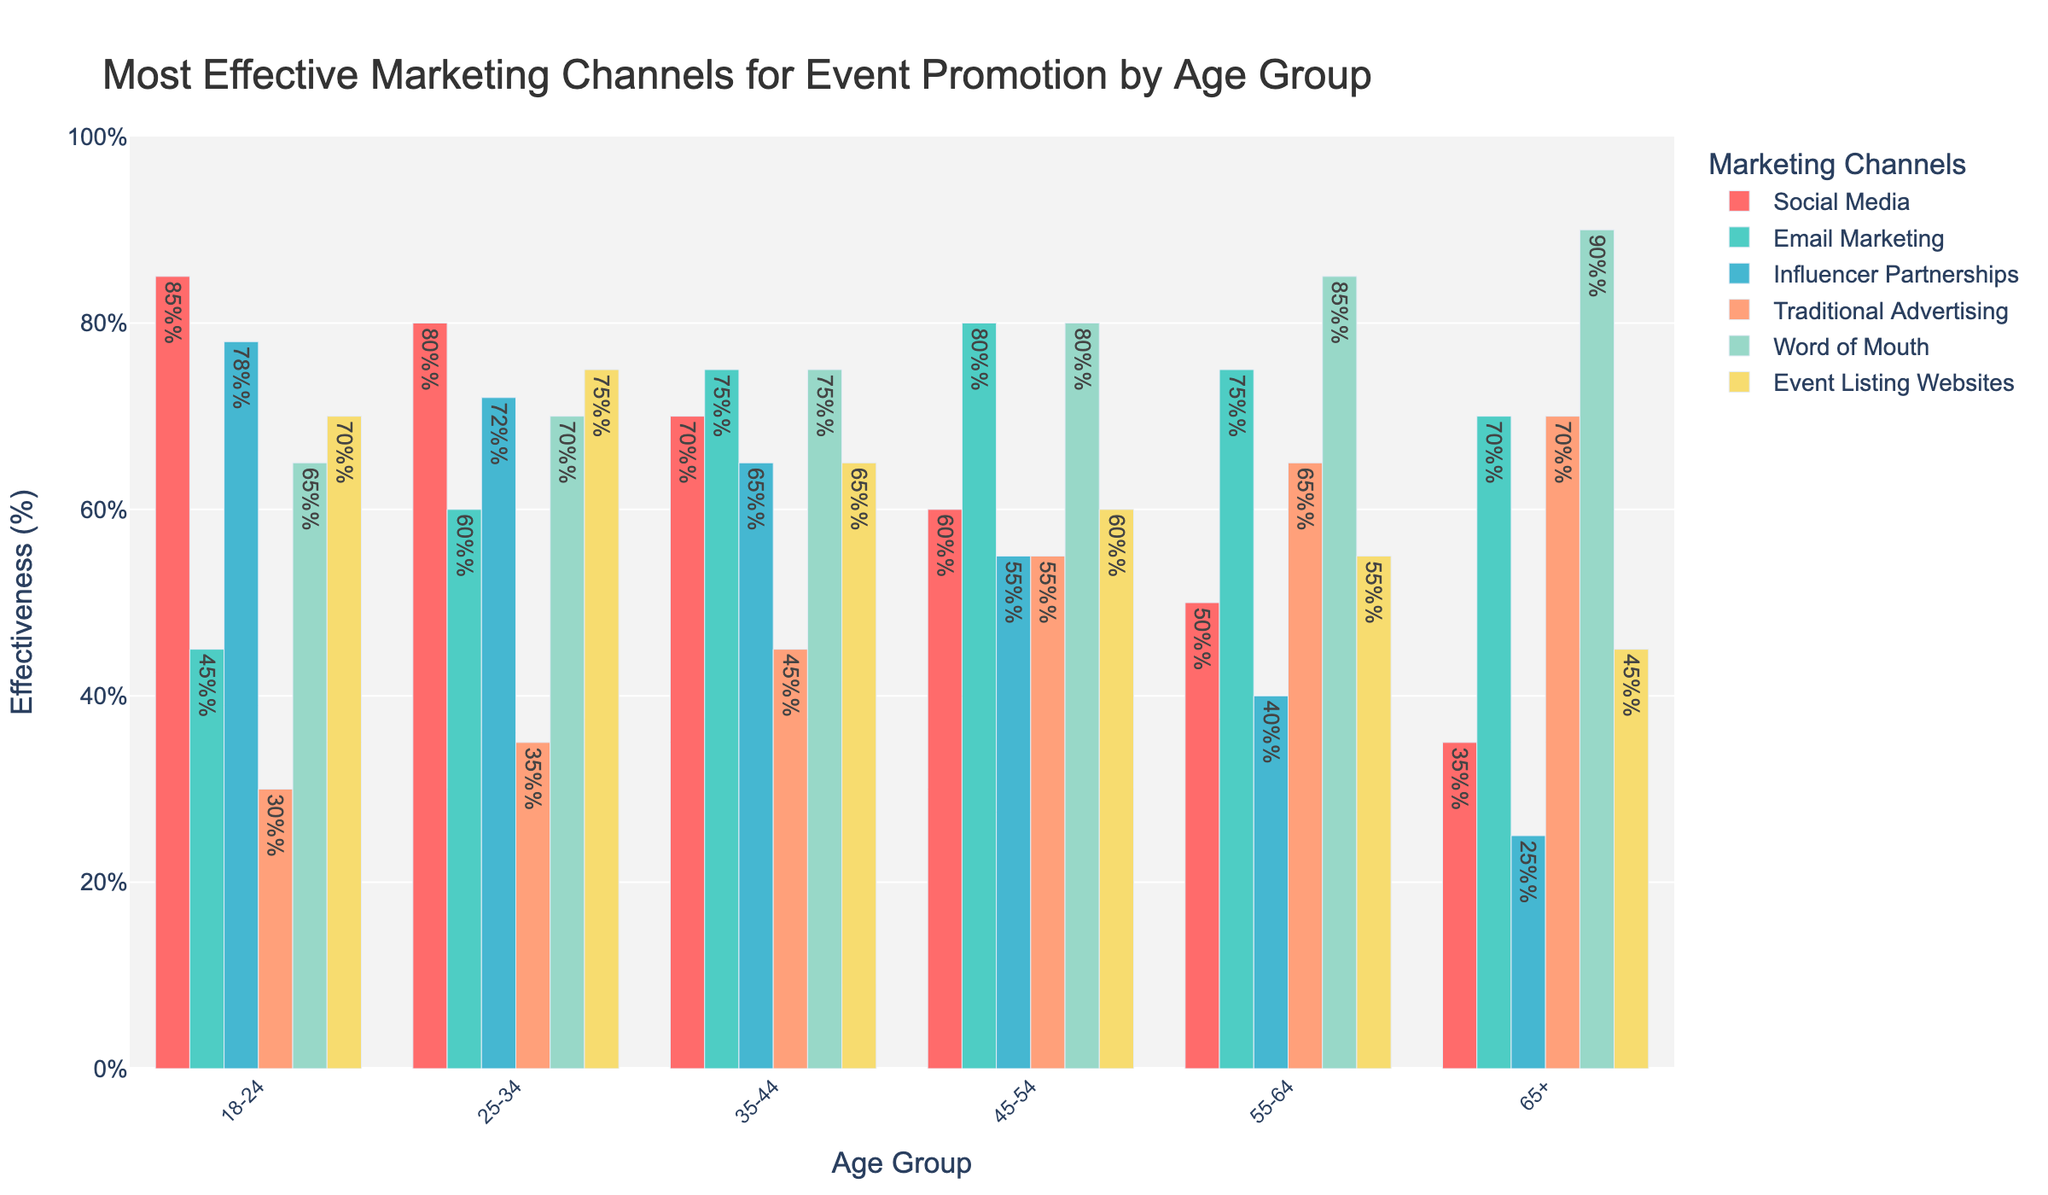What is the most effective marketing channel for the age group 18-24? The tallest bar for the age group 18-24 represents Social Media.
Answer: Social Media Which age group finds Email Marketing most effective? By comparing the heights of the Email Marketing bars across all age groups, the tallest bar is for the age group 45-54.
Answer: 45-54 Which marketing channel shows a declining trend in effectiveness as age increases? Observing the bars for each marketing channel across consecutively increasing age groups, Social Media effectiveness decreases as the age group increases.
Answer: Social Media What is the sum of the effectiveness of Influencer Partnerships and Word of Mouth for the age group 35-44? For the age group 35-44, Influencer Partnerships has a value of 65 and Word of Mouth has a value of 75. Therefore, the sum is 65 + 75 = 140.
Answer: 140 Which age group has the lowest effectiveness for Traditional Advertising, and what is that value? The shortest bar for Traditional Advertising represents the age group 18-24, with a value of 30.
Answer: 18-24, 30 How many marketing channels have an effectiveness of over 70% for the age group 25-34? For the age group 25-34, the bars over 70% are Social Media, Word of Mouth, and Event Listing Websites. There are 3 channels.
Answer: 3 Does any age group consider Influencer Partnerships the most effective marketing channel? By comparing the heights of the bars for Influencer Partnerships and other marketing channels per age group, no age group considers Influencer Partnerships as the most effective.
Answer: No Compare the effectiveness of Word of Mouth for the age group 55-64 with Social Media for the same age group. Which is higher? For the age group 55-64, the bars show that Word of Mouth (85%) is higher than Social Media (50%).
Answer: Word of Mouth What is the average effectiveness of Traditional Advertising for all age groups? Traditional Advertising values across all age groups are 30, 35, 45, 55, 65, 70. Sum these values (30 + 35 + 45 + 55 + 65 + 70 = 300) and divide by 6 (300/6 = 50).
Answer: 50 What is the highest effectiveness percentage for an event listing website, and in which age group does it occur? The tallest bar for Event Listing Websites represents an effectiveness of 75% for the age group 25-34.
Answer: 75%, 25-34 